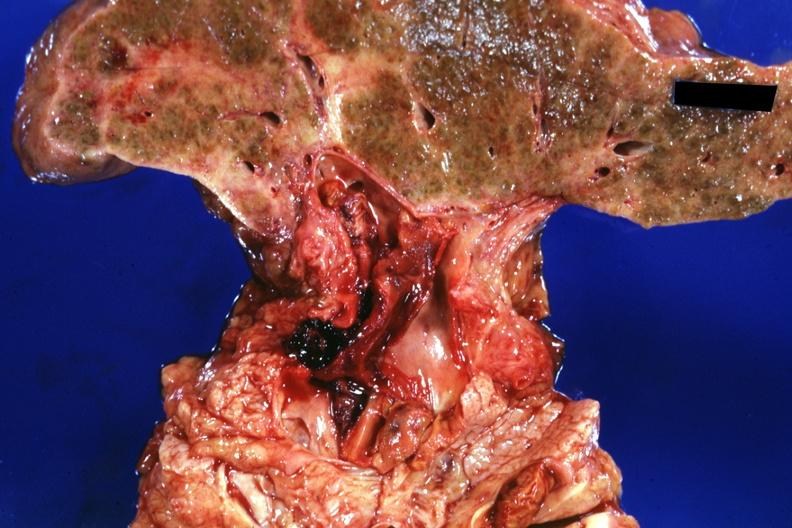s basilar skull fracture present?
Answer the question using a single word or phrase. No 